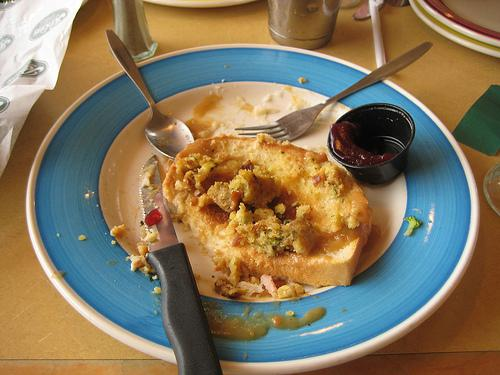Question: what is the color of the plate?
Choices:
A. Black and yellow.
B. Red and blue.
C. Blue and white.
D. Purple and black.
Answer with the letter. Answer: C Question: what is the color of the knife's handle?
Choices:
A. Brown.
B. Yellow.
C. Black.
D. Grey.
Answer with the letter. Answer: C Question: how many fork are on the plate?
Choices:
A. Two.
B. Three.
C. Four.
D. One.
Answer with the letter. Answer: D 